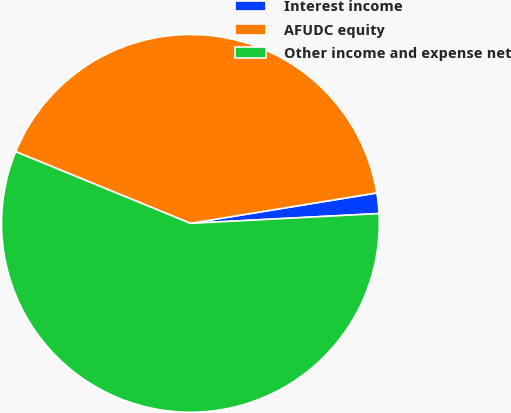<chart> <loc_0><loc_0><loc_500><loc_500><pie_chart><fcel>Interest income<fcel>AFUDC equity<fcel>Other income and expense net<nl><fcel>1.75%<fcel>41.23%<fcel>57.02%<nl></chart> 